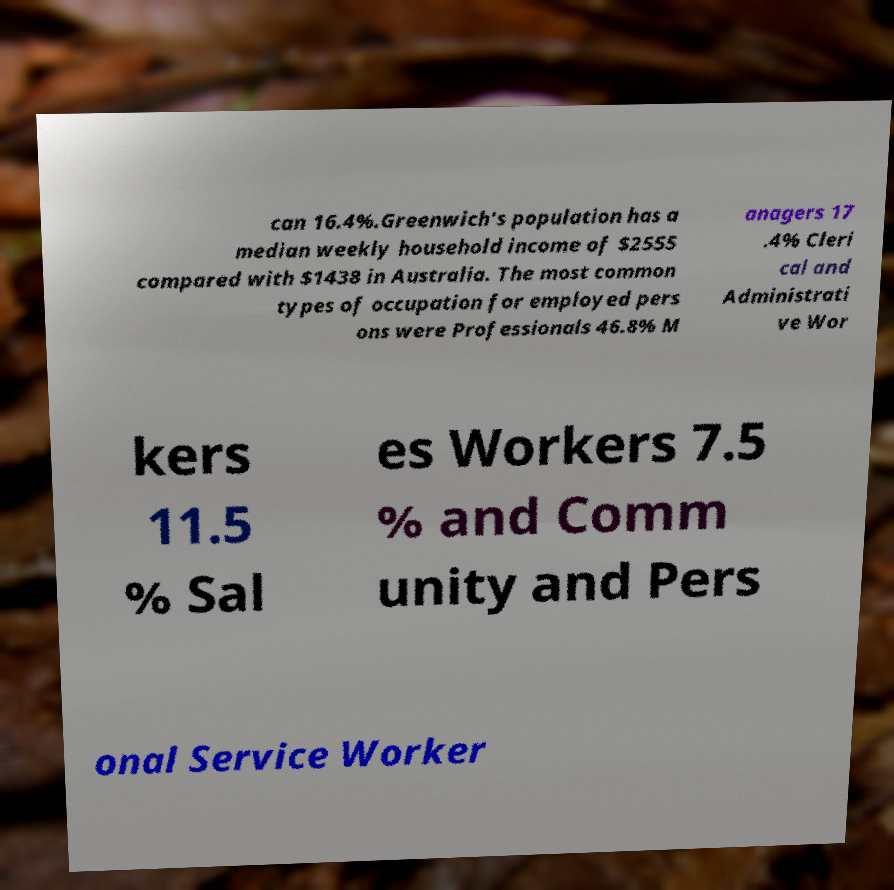What messages or text are displayed in this image? I need them in a readable, typed format. can 16.4%.Greenwich's population has a median weekly household income of $2555 compared with $1438 in Australia. The most common types of occupation for employed pers ons were Professionals 46.8% M anagers 17 .4% Cleri cal and Administrati ve Wor kers 11.5 % Sal es Workers 7.5 % and Comm unity and Pers onal Service Worker 